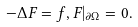Convert formula to latex. <formula><loc_0><loc_0><loc_500><loc_500>- \Delta F = f , F | _ { \partial \Omega } = 0 .</formula> 